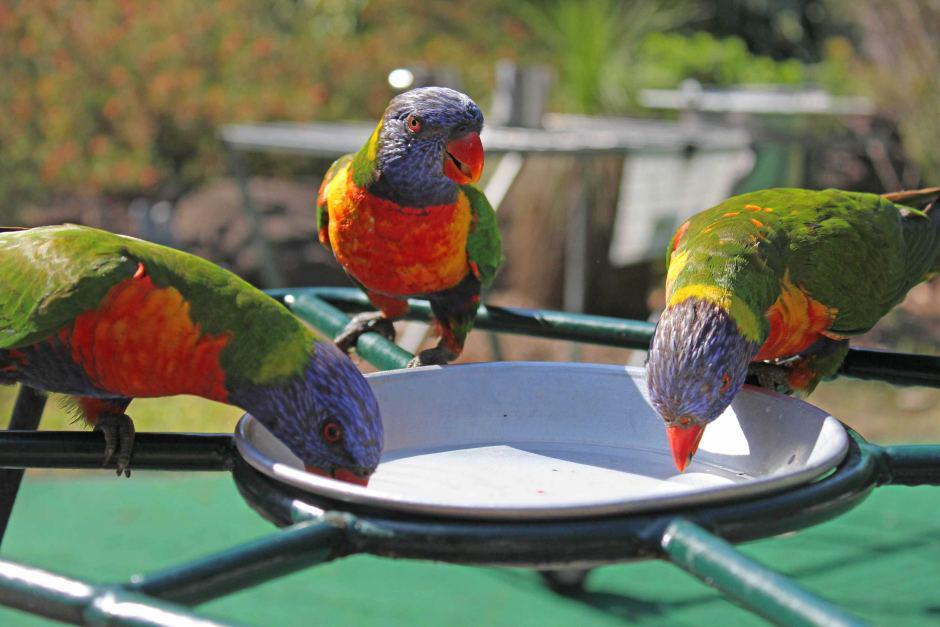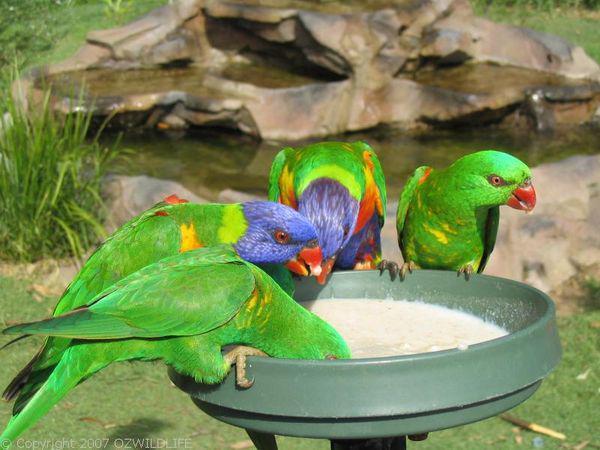The first image is the image on the left, the second image is the image on the right. For the images shown, is this caption "At least one image shows multiple parrots with beaks bent toward a round pan and does not show any human faces." true? Answer yes or no. Yes. The first image is the image on the left, the second image is the image on the right. Evaluate the accuracy of this statement regarding the images: "Birds are perched on a person in the image on the left.". Is it true? Answer yes or no. No. 